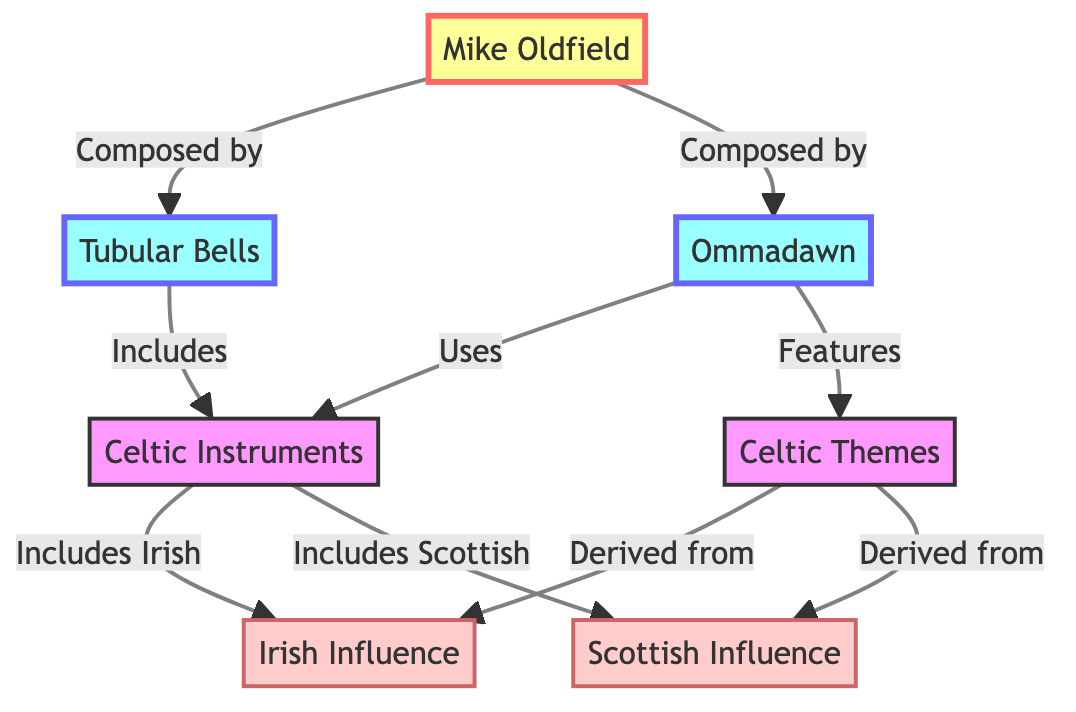What are the two albums composed by Mike Oldfield? The diagram shows Mike Oldfield connected to two albums: Tubular Bells and Ommadawn. These are the titles listed directly under his name.
Answer: Tubular Bells, Ommadawn How many influences are listed in the diagram? The diagram shows two influences connected to Celtic Themes: Irish Influence and Scottish Influence. Counting these connections reveals that there are two distinct influences.
Answer: 2 Which album includes Celtic Instruments? The diagram indicates that Tubular Bells includes Celtic Instruments through a direct connection. This is explicitly stated in the relationship from the album to the instruments.
Answer: Tubular Bells What do Celtic Themes derive from? The diagram connects Celtic Themes to two other nodes, specifically Irish Influence and Scottish Influence. Therefore, Celtic Themes are derived from these two influences.
Answer: Irish Influence, Scottish Influence How many albums has Mike Oldfield composed that are mentioned in the diagram? The diagram shows that Mike Oldfield has composed two albums that are explicitly mentioned: Tubular Bells and Ommadawn. By counting the connections to these albums, you can determine the total.
Answer: 2 What is the relationship between Ommadawn and Celtic Instruments? The diagram illustrates that Ommadawn uses Celtic Instruments, as denoted by the directed arrow from Ommadawn to Celtic Instruments. This indicates a direct utilization in the album.
Answer: Uses Which influences are included in Celtic Instruments? The diagram indicates that Celtic Instruments includes both Irish and Scottish influences through direct connections. This means both are part of the broader category of Celtic Instruments.
Answer: Irish, Scottish Identify the node that represents the composer of the albums. The diagram clearly identifies Mike Oldfield as the node connected to the albums. This is indicated at the very top as the starting point of the relationships.
Answer: Mike Oldfield 